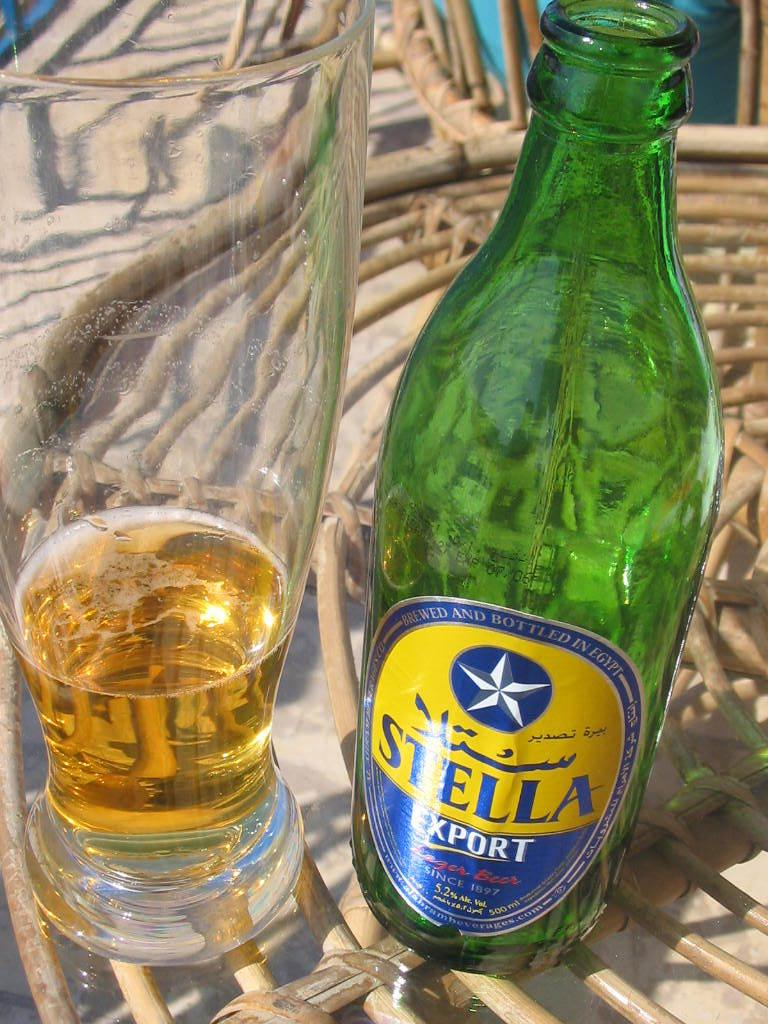<image>
Share a concise interpretation of the image provided. A bottle of Stella export is poured into a tall glass. 